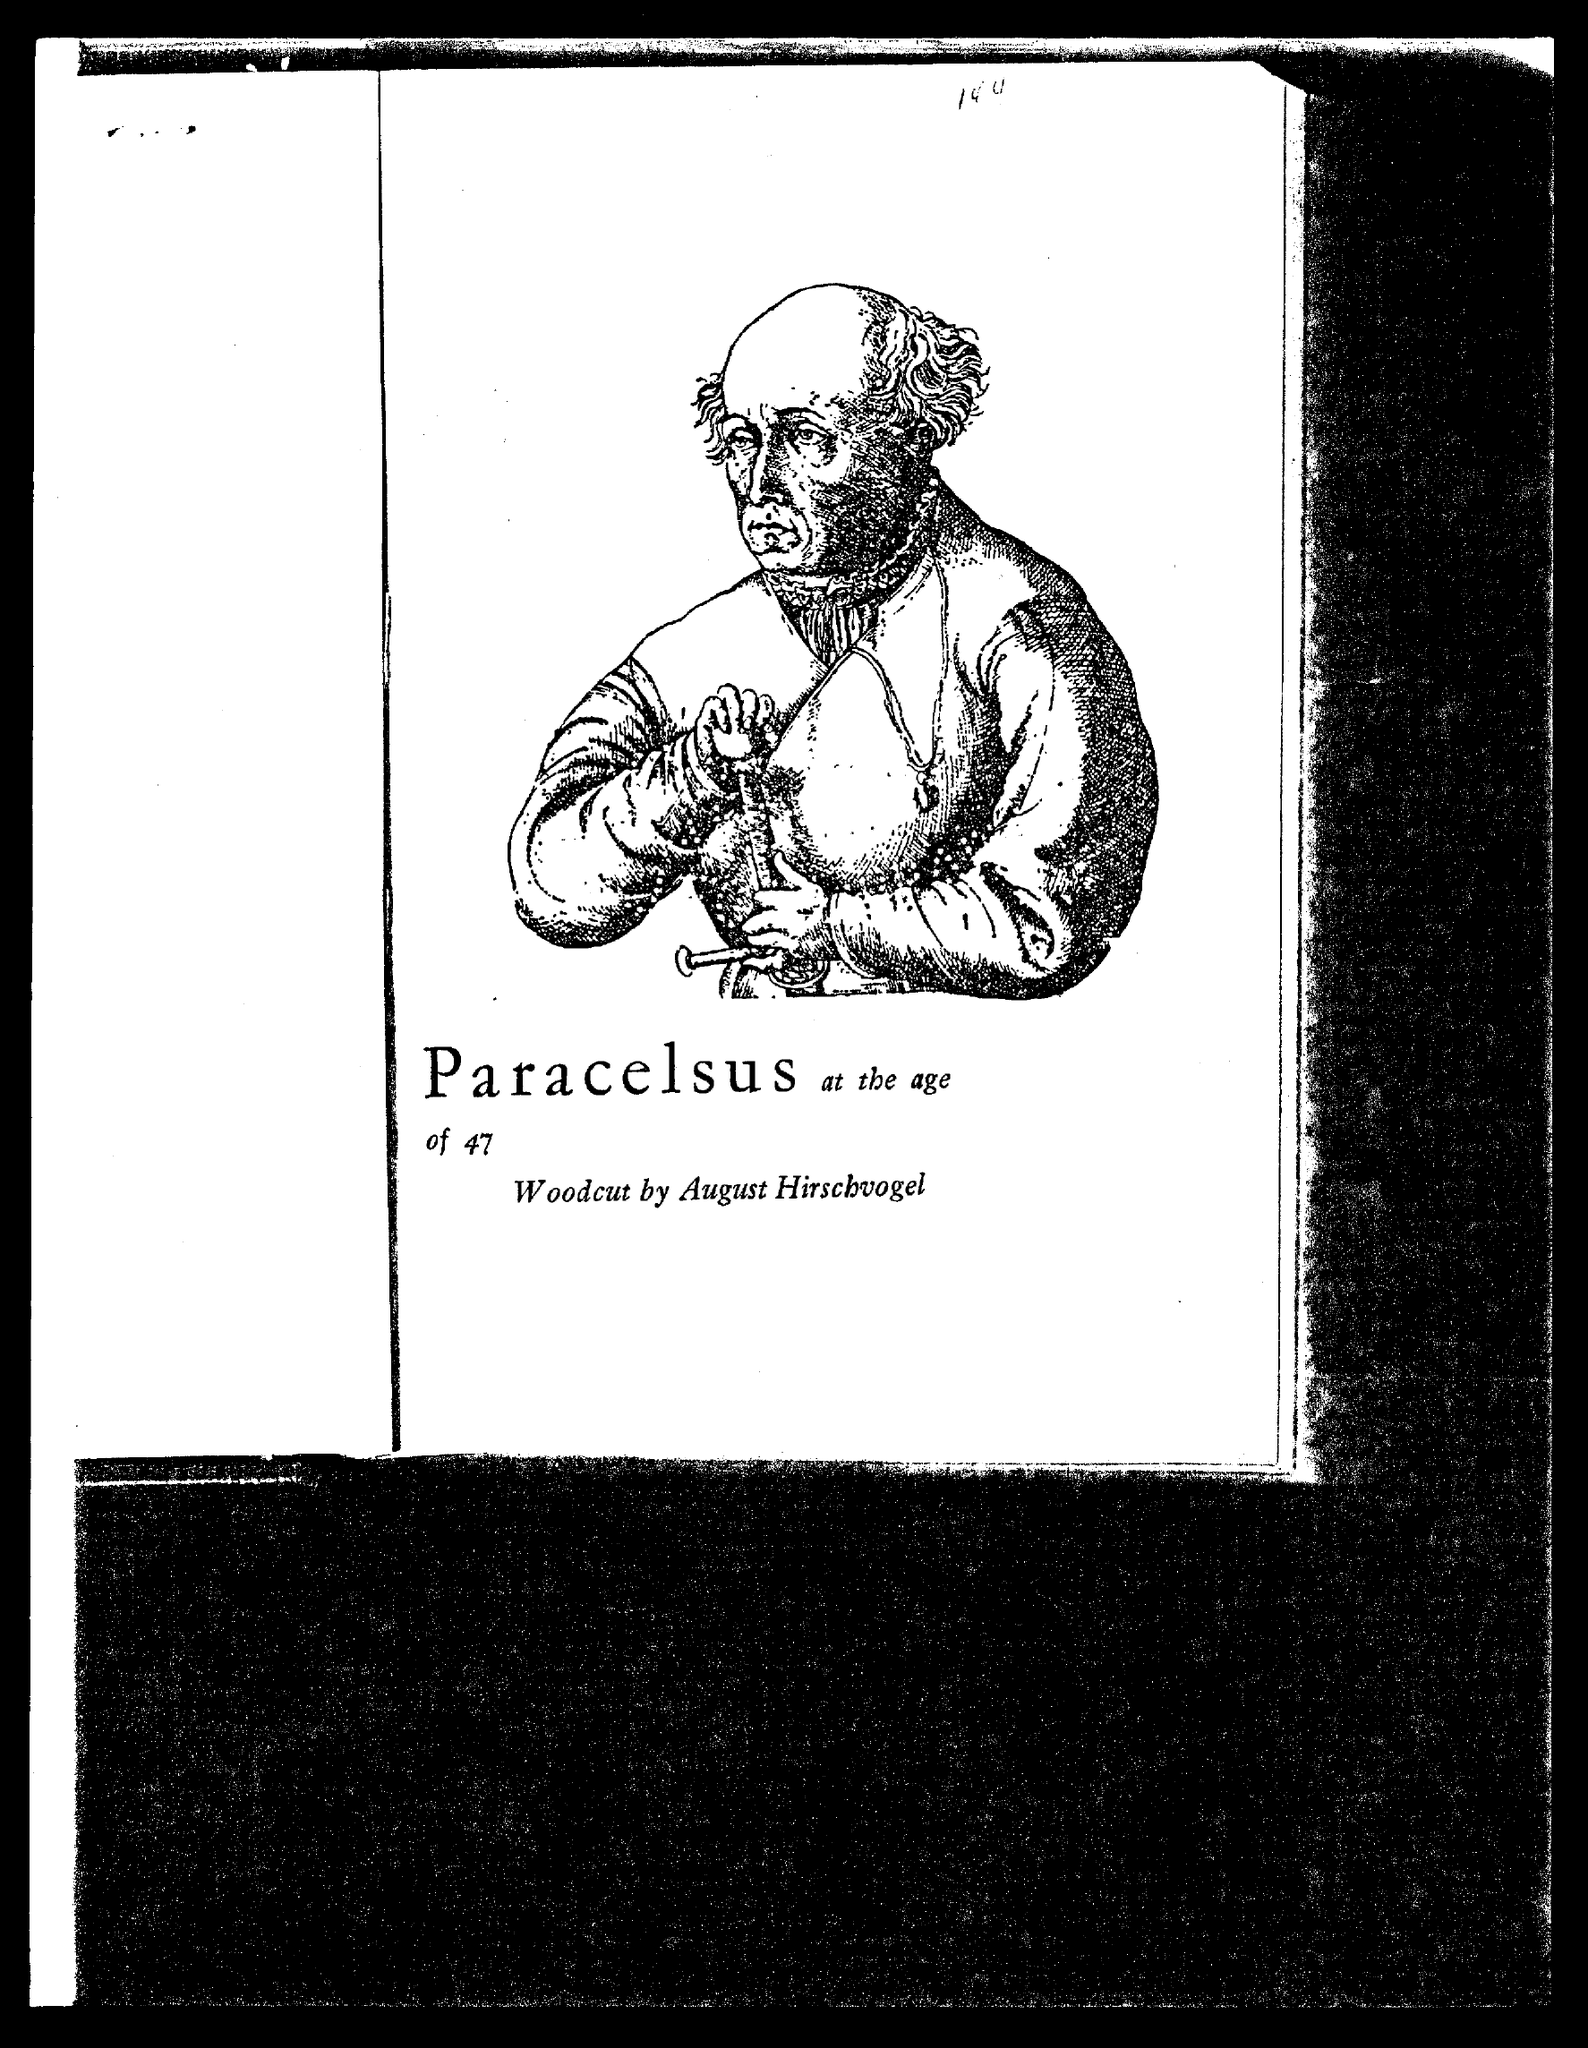Indicate a few pertinent items in this graphic. The person in the picture is Paracelsus. The age of Paracelsus in the picture is 47. 